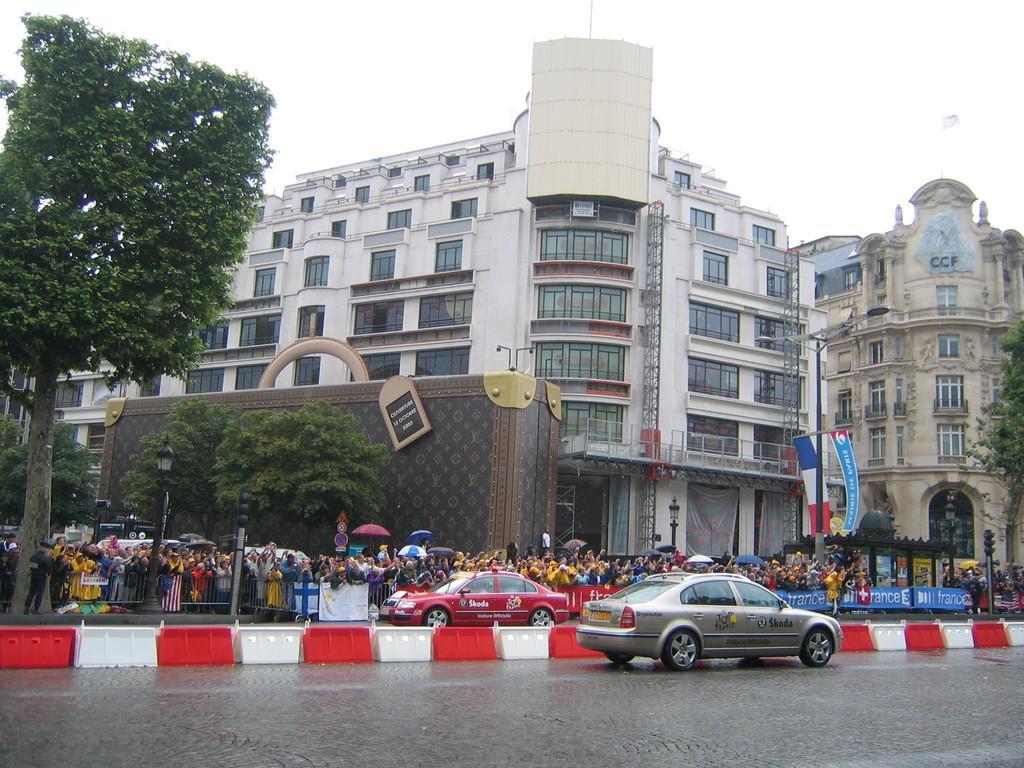Can you describe this image briefly? In this image there is the sky towards the top of the image, there are buildings, there are windows, there are a group of persons standing, there is a metal fence, there are flags, there is a pole, there is a street light, there are trees towards the left of the image, there is a tree towards the right of the image, there is road towards the bottom of the image, there are cars on the road, there is text on the cars. 